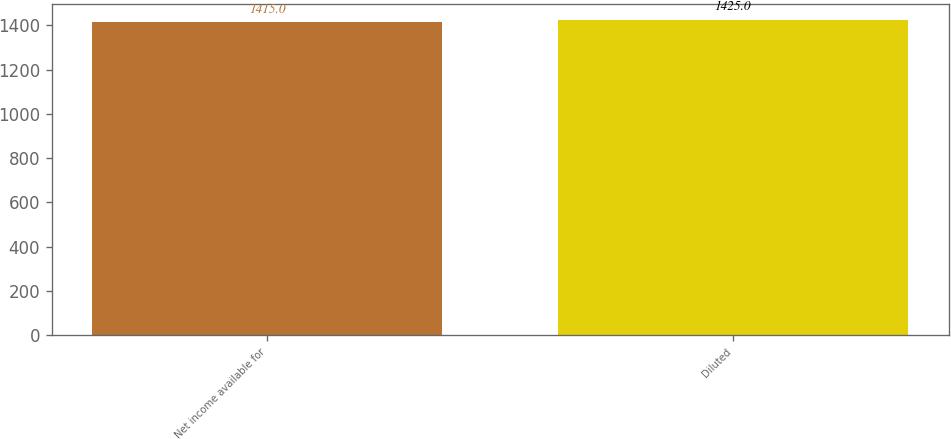Convert chart. <chart><loc_0><loc_0><loc_500><loc_500><bar_chart><fcel>Net income available for<fcel>Diluted<nl><fcel>1415<fcel>1425<nl></chart> 